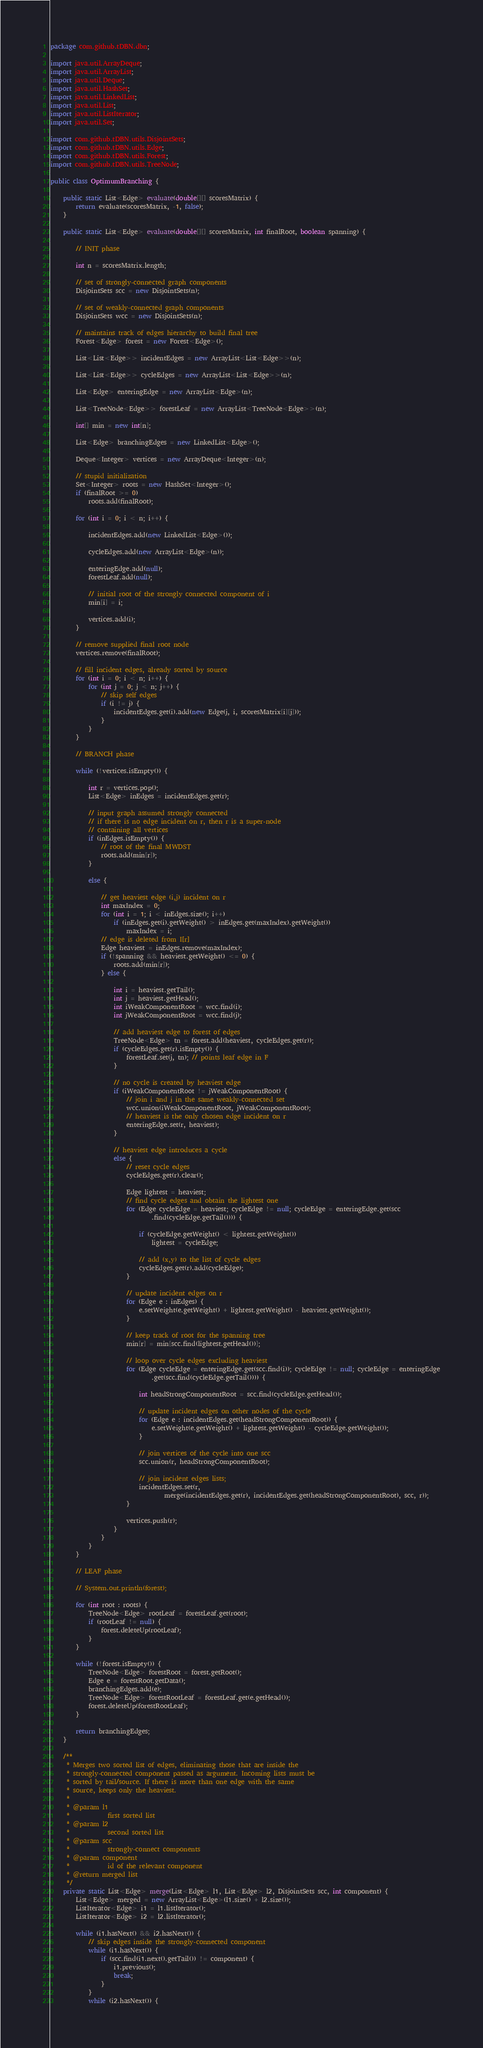<code> <loc_0><loc_0><loc_500><loc_500><_Java_>package com.github.tDBN.dbn;

import java.util.ArrayDeque;
import java.util.ArrayList;
import java.util.Deque;
import java.util.HashSet;
import java.util.LinkedList;
import java.util.List;
import java.util.ListIterator;
import java.util.Set;

import com.github.tDBN.utils.DisjointSets;
import com.github.tDBN.utils.Edge;
import com.github.tDBN.utils.Forest;
import com.github.tDBN.utils.TreeNode;

public class OptimumBranching {

	public static List<Edge> evaluate(double[][] scoresMatrix) {
		return evaluate(scoresMatrix, -1, false);
	}

	public static List<Edge> evaluate(double[][] scoresMatrix, int finalRoot, boolean spanning) {

		// INIT phase

		int n = scoresMatrix.length;

		// set of strongly-connected graph components
		DisjointSets scc = new DisjointSets(n);

		// set of weakly-connected graph components
		DisjointSets wcc = new DisjointSets(n);

		// maintains track of edges hierarchy to build final tree
		Forest<Edge> forest = new Forest<Edge>();

		List<List<Edge>> incidentEdges = new ArrayList<List<Edge>>(n);

		List<List<Edge>> cycleEdges = new ArrayList<List<Edge>>(n);

		List<Edge> enteringEdge = new ArrayList<Edge>(n);

		List<TreeNode<Edge>> forestLeaf = new ArrayList<TreeNode<Edge>>(n);

		int[] min = new int[n];

		List<Edge> branchingEdges = new LinkedList<Edge>();

		Deque<Integer> vertices = new ArrayDeque<Integer>(n);

		// stupid initialization
		Set<Integer> roots = new HashSet<Integer>();
		if (finalRoot >= 0)
			roots.add(finalRoot);

		for (int i = 0; i < n; i++) {

			incidentEdges.add(new LinkedList<Edge>());

			cycleEdges.add(new ArrayList<Edge>(n));

			enteringEdge.add(null);
			forestLeaf.add(null);

			// initial root of the strongly connected component of i
			min[i] = i;

			vertices.add(i);
		}

		// remove supplied final root node
		vertices.remove(finalRoot);

		// fill incident edges, already sorted by source
		for (int i = 0; i < n; i++) {
			for (int j = 0; j < n; j++) {
				// skip self edges
				if (i != j) {
					incidentEdges.get(i).add(new Edge(j, i, scoresMatrix[i][j]));
				}
			}
		}

		// BRANCH phase

		while (!vertices.isEmpty()) {

			int r = vertices.pop();
			List<Edge> inEdges = incidentEdges.get(r);

			// input graph assumed strongly connected
			// if there is no edge incident on r, then r is a super-node
			// containing all vertices
			if (inEdges.isEmpty()) {
				// root of the final MWDST
				roots.add(min[r]);
			}

			else {

				// get heaviest edge (i,j) incident on r
				int maxIndex = 0;
				for (int i = 1; i < inEdges.size(); i++)
					if (inEdges.get(i).getWeight() > inEdges.get(maxIndex).getWeight())
						maxIndex = i;
				// edge is deleted from I[r]
				Edge heaviest = inEdges.remove(maxIndex);
				if (!spanning && heaviest.getWeight() <= 0) {
					roots.add(min[r]);
				} else {

					int i = heaviest.getTail();
					int j = heaviest.getHead();
					int iWeakComponentRoot = wcc.find(i);
					int jWeakComponentRoot = wcc.find(j);

					// add heaviest edge to forest of edges
					TreeNode<Edge> tn = forest.add(heaviest, cycleEdges.get(r));
					if (cycleEdges.get(r).isEmpty()) {
						forestLeaf.set(j, tn); // points leaf edge in F
					}

					// no cycle is created by heaviest edge
					if (iWeakComponentRoot != jWeakComponentRoot) {
						// join i and j in the same weakly-connected set
						wcc.union(iWeakComponentRoot, jWeakComponentRoot);
						// heaviest is the only chosen edge incident on r
						enteringEdge.set(r, heaviest);
					}

					// heaviest edge introduces a cycle
					else {
						// reset cycle edges
						cycleEdges.get(r).clear();

						Edge lightest = heaviest;
						// find cycle edges and obtain the lightest one
						for (Edge cycleEdge = heaviest; cycleEdge != null; cycleEdge = enteringEdge.get(scc
								.find(cycleEdge.getTail()))) {

							if (cycleEdge.getWeight() < lightest.getWeight())
								lightest = cycleEdge;

							// add (x,y) to the list of cycle edges
							cycleEdges.get(r).add(cycleEdge);
						}

						// update incident edges on r
						for (Edge e : inEdges) {
							e.setWeight(e.getWeight() + lightest.getWeight() - heaviest.getWeight());
						}

						// keep track of root for the spanning tree
						min[r] = min[scc.find(lightest.getHead())];

						// loop over cycle edges excluding heaviest
						for (Edge cycleEdge = enteringEdge.get(scc.find(i)); cycleEdge != null; cycleEdge = enteringEdge
								.get(scc.find(cycleEdge.getTail()))) {

							int headStrongComponentRoot = scc.find(cycleEdge.getHead());

							// update incident edges on other nodes of the cycle
							for (Edge e : incidentEdges.get(headStrongComponentRoot)) {
								e.setWeight(e.getWeight() + lightest.getWeight() - cycleEdge.getWeight());
							}

							// join vertices of the cycle into one scc
							scc.union(r, headStrongComponentRoot);

							// join incident edges lists;
							incidentEdges.set(r,
									merge(incidentEdges.get(r), incidentEdges.get(headStrongComponentRoot), scc, r));
						}

						vertices.push(r);
					}
				}
			}
		}

		// LEAF phase

		// System.out.println(forest);

		for (int root : roots) {
			TreeNode<Edge> rootLeaf = forestLeaf.get(root);
			if (rootLeaf != null) {
				forest.deleteUp(rootLeaf);
			}
		}

		while (!forest.isEmpty()) {
			TreeNode<Edge> forestRoot = forest.getRoot();
			Edge e = forestRoot.getData();
			branchingEdges.add(e);
			TreeNode<Edge> forestRootLeaf = forestLeaf.get(e.getHead());
			forest.deleteUp(forestRootLeaf);
		}

		return branchingEdges;
	}

	/**
	 * Merges two sorted list of edges, eliminating those that are inside the
	 * strongly-connected component passed as argument. Incoming lists must be
	 * sorted by tail/source. If there is more than one edge with the same
	 * source, keeps only the heaviest.
	 * 
	 * @param l1
	 *            first sorted list
	 * @param l2
	 *            second sorted list
	 * @param scc
	 *            strongly-connect components
	 * @param component
	 *            id of the relevant component
	 * @return merged list
	 */
	private static List<Edge> merge(List<Edge> l1, List<Edge> l2, DisjointSets scc, int component) {
		List<Edge> merged = new ArrayList<Edge>(l1.size() + l2.size());
		ListIterator<Edge> i1 = l1.listIterator();
		ListIterator<Edge> i2 = l2.listIterator();

		while (i1.hasNext() && i2.hasNext()) {
			// skip edges inside the strongly-connected component
			while (i1.hasNext()) {
				if (scc.find(i1.next().getTail()) != component) {
					i1.previous();
					break;
				}
			}
			while (i2.hasNext()) {</code> 